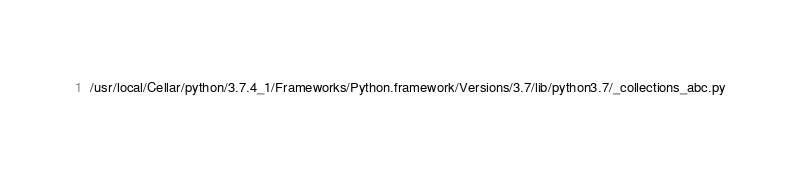<code> <loc_0><loc_0><loc_500><loc_500><_Python_>/usr/local/Cellar/python/3.7.4_1/Frameworks/Python.framework/Versions/3.7/lib/python3.7/_collections_abc.py</code> 